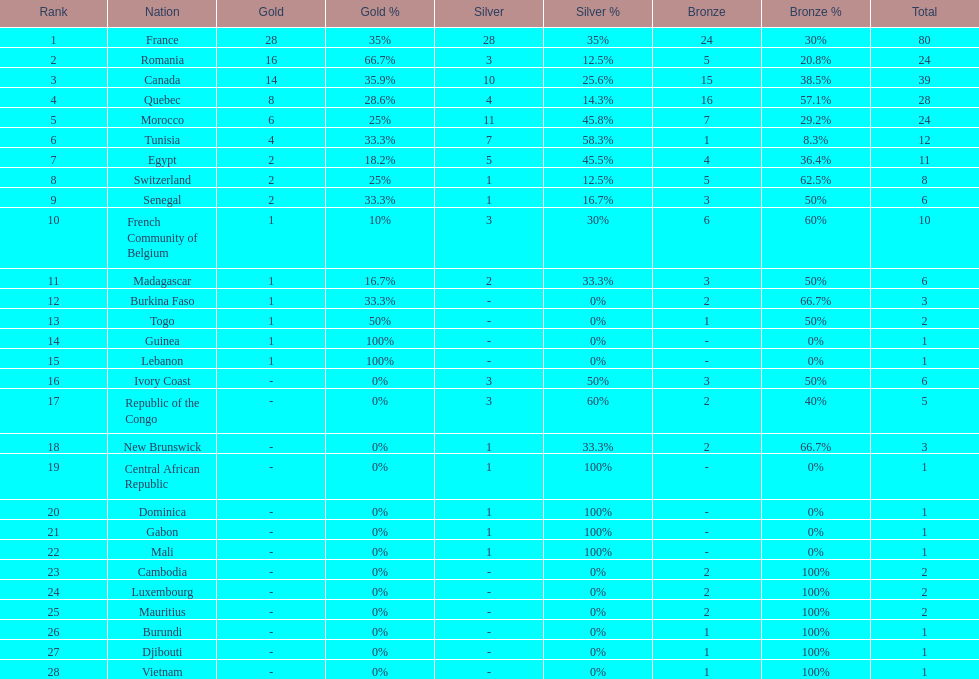What is the difference between france's and egypt's silver medals? 23. 